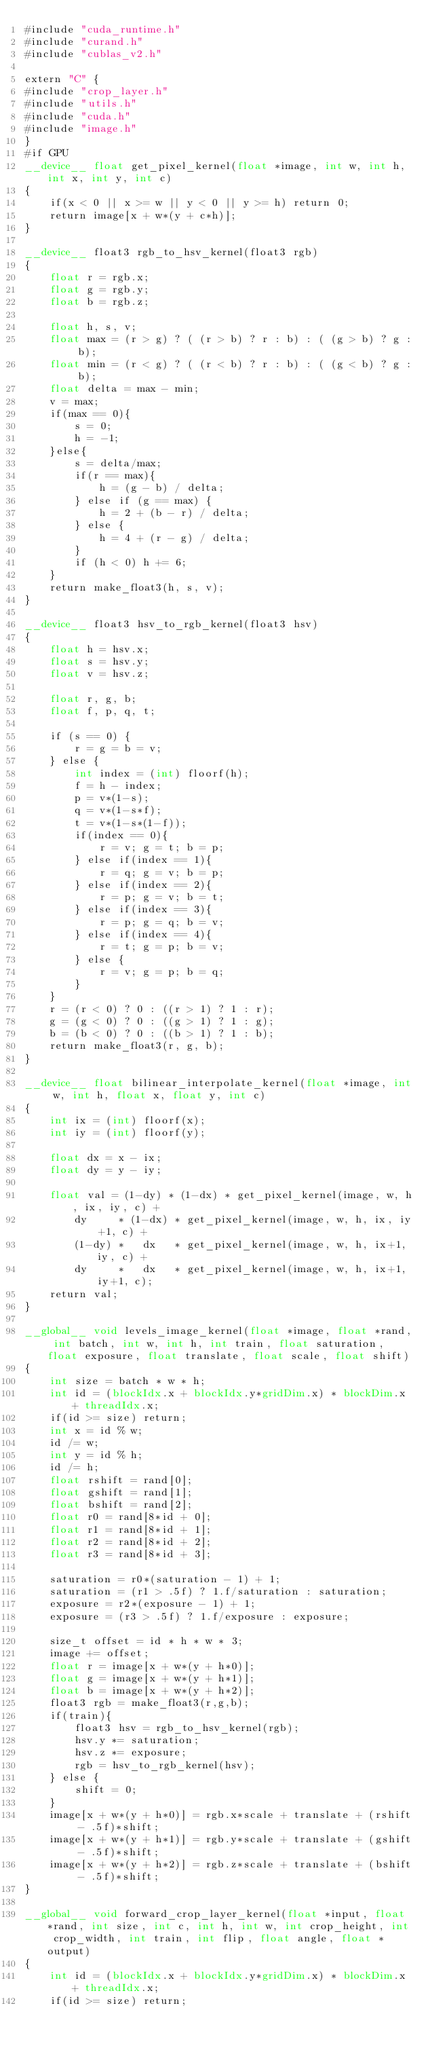<code> <loc_0><loc_0><loc_500><loc_500><_Cuda_>#include "cuda_runtime.h"
#include "curand.h"
#include "cublas_v2.h"

extern "C" {
#include "crop_layer.h"
#include "utils.h"
#include "cuda.h"
#include "image.h"
}
#if GPU 
__device__ float get_pixel_kernel(float *image, int w, int h, int x, int y, int c)
{
    if(x < 0 || x >= w || y < 0 || y >= h) return 0;
    return image[x + w*(y + c*h)];
}

__device__ float3 rgb_to_hsv_kernel(float3 rgb)
{
    float r = rgb.x;
    float g = rgb.y; 
    float b = rgb.z;

    float h, s, v;
    float max = (r > g) ? ( (r > b) ? r : b) : ( (g > b) ? g : b);
    float min = (r < g) ? ( (r < b) ? r : b) : ( (g < b) ? g : b);
    float delta = max - min;
    v = max;
    if(max == 0){
        s = 0;
        h = -1;
    }else{
        s = delta/max;
        if(r == max){
            h = (g - b) / delta;
        } else if (g == max) {
            h = 2 + (b - r) / delta;
        } else {
            h = 4 + (r - g) / delta;
        }
        if (h < 0) h += 6;
    }
    return make_float3(h, s, v);
}

__device__ float3 hsv_to_rgb_kernel(float3 hsv)
{
    float h = hsv.x;
    float s = hsv.y; 
    float v = hsv.z;

    float r, g, b;
    float f, p, q, t;

    if (s == 0) {
        r = g = b = v;
    } else {
        int index = (int) floorf(h);
        f = h - index;
        p = v*(1-s);
        q = v*(1-s*f);
        t = v*(1-s*(1-f));
        if(index == 0){
            r = v; g = t; b = p;
        } else if(index == 1){
            r = q; g = v; b = p;
        } else if(index == 2){
            r = p; g = v; b = t;
        } else if(index == 3){
            r = p; g = q; b = v;
        } else if(index == 4){
            r = t; g = p; b = v;
        } else {
            r = v; g = p; b = q;
        }
    }
    r = (r < 0) ? 0 : ((r > 1) ? 1 : r);
    g = (g < 0) ? 0 : ((g > 1) ? 1 : g);
    b = (b < 0) ? 0 : ((b > 1) ? 1 : b);
    return make_float3(r, g, b);
}

__device__ float bilinear_interpolate_kernel(float *image, int w, int h, float x, float y, int c)
{
    int ix = (int) floorf(x);
    int iy = (int) floorf(y);

    float dx = x - ix;
    float dy = y - iy;

    float val = (1-dy) * (1-dx) * get_pixel_kernel(image, w, h, ix, iy, c) + 
        dy     * (1-dx) * get_pixel_kernel(image, w, h, ix, iy+1, c) + 
        (1-dy) *   dx   * get_pixel_kernel(image, w, h, ix+1, iy, c) +
        dy     *   dx   * get_pixel_kernel(image, w, h, ix+1, iy+1, c);
    return val;
}

__global__ void levels_image_kernel(float *image, float *rand, int batch, int w, int h, int train, float saturation, float exposure, float translate, float scale, float shift)
{
    int size = batch * w * h;
    int id = (blockIdx.x + blockIdx.y*gridDim.x) * blockDim.x + threadIdx.x;
    if(id >= size) return;
    int x = id % w;
    id /= w;
    int y = id % h;
    id /= h;
    float rshift = rand[0];
    float gshift = rand[1];
    float bshift = rand[2];
    float r0 = rand[8*id + 0];
    float r1 = rand[8*id + 1];
    float r2 = rand[8*id + 2];
    float r3 = rand[8*id + 3];

    saturation = r0*(saturation - 1) + 1;
    saturation = (r1 > .5f) ? 1.f/saturation : saturation;
    exposure = r2*(exposure - 1) + 1;
    exposure = (r3 > .5f) ? 1.f/exposure : exposure;

    size_t offset = id * h * w * 3;
    image += offset;
    float r = image[x + w*(y + h*0)];
    float g = image[x + w*(y + h*1)];
    float b = image[x + w*(y + h*2)];
    float3 rgb = make_float3(r,g,b);
    if(train){
        float3 hsv = rgb_to_hsv_kernel(rgb);
        hsv.y *= saturation;
        hsv.z *= exposure;
        rgb = hsv_to_rgb_kernel(hsv);
    } else {
        shift = 0;
    }
    image[x + w*(y + h*0)] = rgb.x*scale + translate + (rshift - .5f)*shift;
    image[x + w*(y + h*1)] = rgb.y*scale + translate + (gshift - .5f)*shift;
    image[x + w*(y + h*2)] = rgb.z*scale + translate + (bshift - .5f)*shift;
}

__global__ void forward_crop_layer_kernel(float *input, float *rand, int size, int c, int h, int w, int crop_height, int crop_width, int train, int flip, float angle, float *output)
{
    int id = (blockIdx.x + blockIdx.y*gridDim.x) * blockDim.x + threadIdx.x;
    if(id >= size) return;
</code> 